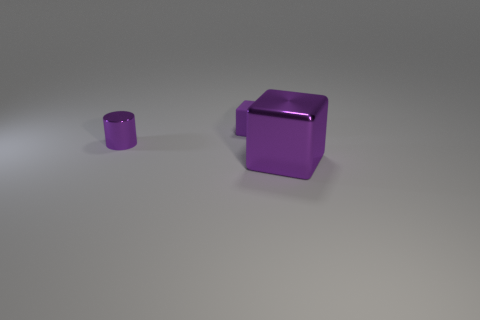Is the number of tiny cylinders behind the rubber block less than the number of purple matte blocks that are in front of the tiny shiny object?
Give a very brief answer. No. Are the cylinder and the purple thing on the right side of the rubber object made of the same material?
Make the answer very short. Yes. Is there any other thing that is made of the same material as the small purple block?
Keep it short and to the point. No. Are there more small metal things than small gray blocks?
Your response must be concise. Yes. There is a metallic thing on the left side of the block in front of the purple cube behind the tiny metallic cylinder; what shape is it?
Provide a short and direct response. Cylinder. Do the purple thing behind the purple cylinder and the purple cylinder behind the big metallic object have the same material?
Offer a terse response. No. There is a tiny purple object that is made of the same material as the big purple thing; what is its shape?
Your answer should be very brief. Cylinder. Is there anything else that is the same color as the metal block?
Make the answer very short. Yes. How many tiny metallic cylinders are there?
Your answer should be compact. 1. What material is the small purple object that is behind the purple shiny thing that is left of the matte block?
Give a very brief answer. Rubber. 